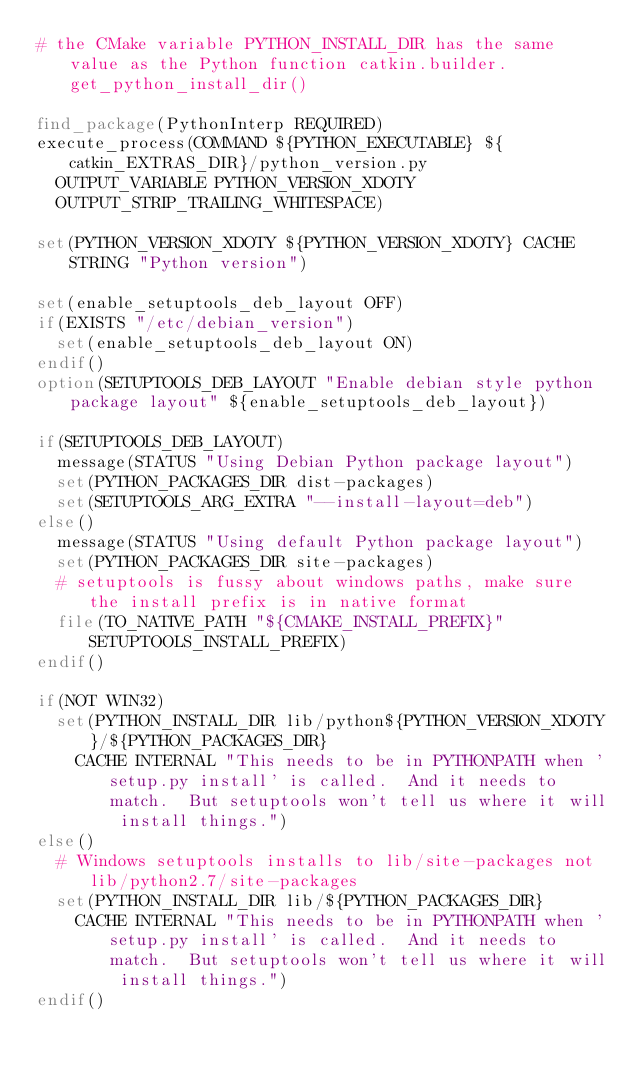Convert code to text. <code><loc_0><loc_0><loc_500><loc_500><_CMake_># the CMake variable PYTHON_INSTALL_DIR has the same value as the Python function catkin.builder.get_python_install_dir()

find_package(PythonInterp REQUIRED)
execute_process(COMMAND ${PYTHON_EXECUTABLE} ${catkin_EXTRAS_DIR}/python_version.py
  OUTPUT_VARIABLE PYTHON_VERSION_XDOTY
  OUTPUT_STRIP_TRAILING_WHITESPACE)

set(PYTHON_VERSION_XDOTY ${PYTHON_VERSION_XDOTY} CACHE STRING "Python version")

set(enable_setuptools_deb_layout OFF)
if(EXISTS "/etc/debian_version")
  set(enable_setuptools_deb_layout ON)
endif()
option(SETUPTOOLS_DEB_LAYOUT "Enable debian style python package layout" ${enable_setuptools_deb_layout})

if(SETUPTOOLS_DEB_LAYOUT)
  message(STATUS "Using Debian Python package layout")
  set(PYTHON_PACKAGES_DIR dist-packages)
  set(SETUPTOOLS_ARG_EXTRA "--install-layout=deb")
else()
  message(STATUS "Using default Python package layout")
  set(PYTHON_PACKAGES_DIR site-packages)
  # setuptools is fussy about windows paths, make sure the install prefix is in native format
  file(TO_NATIVE_PATH "${CMAKE_INSTALL_PREFIX}" SETUPTOOLS_INSTALL_PREFIX)
endif()

if(NOT WIN32)
  set(PYTHON_INSTALL_DIR lib/python${PYTHON_VERSION_XDOTY}/${PYTHON_PACKAGES_DIR}
    CACHE INTERNAL "This needs to be in PYTHONPATH when 'setup.py install' is called.  And it needs to match.  But setuptools won't tell us where it will install things.")
else()
  # Windows setuptools installs to lib/site-packages not lib/python2.7/site-packages 
  set(PYTHON_INSTALL_DIR lib/${PYTHON_PACKAGES_DIR}
    CACHE INTERNAL "This needs to be in PYTHONPATH when 'setup.py install' is called.  And it needs to match.  But setuptools won't tell us where it will install things.")
endif()
</code> 